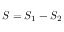Convert formula to latex. <formula><loc_0><loc_0><loc_500><loc_500>S = S _ { 1 } - S _ { 2 }</formula> 